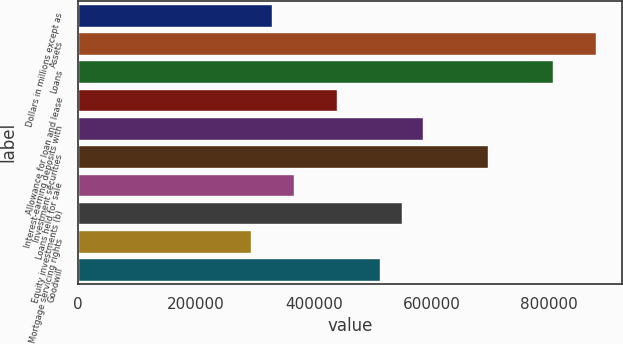<chart> <loc_0><loc_0><loc_500><loc_500><bar_chart><fcel>Dollars in millions except as<fcel>Assets<fcel>Loans<fcel>Allowance for loan and lease<fcel>Interest-earning deposits with<fcel>Investment securities<fcel>Loans held for sale<fcel>Equity investments (b)<fcel>Mortgage servicing rights<fcel>Goodwill<nl><fcel>329743<fcel>879298<fcel>806024<fcel>439654<fcel>586202<fcel>696113<fcel>366380<fcel>549565<fcel>293106<fcel>512928<nl></chart> 